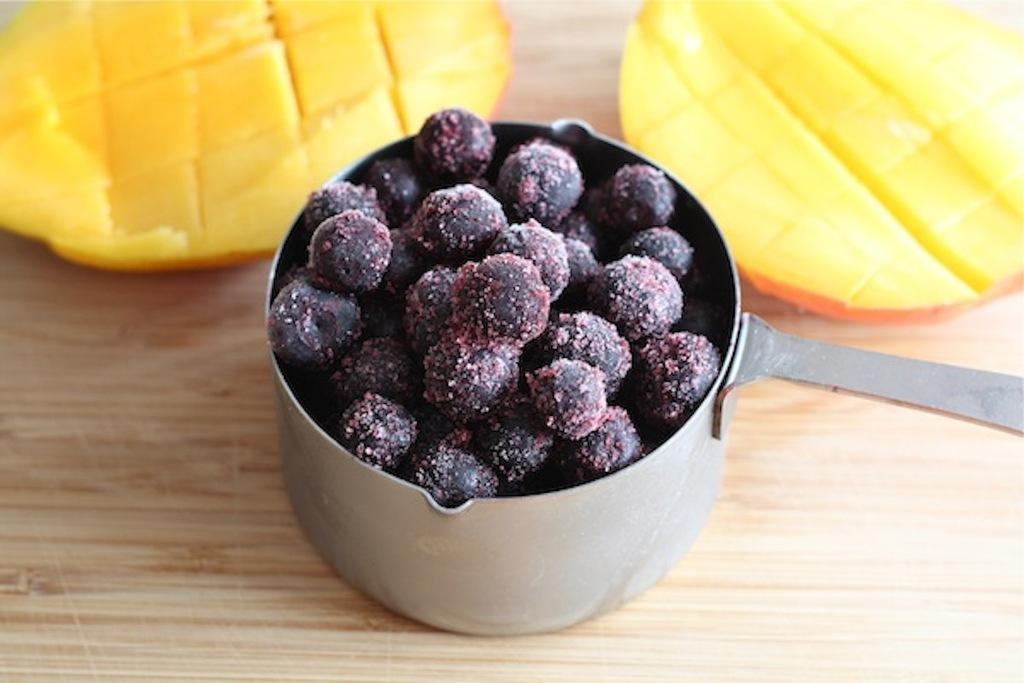What is in the bowl that is visible in the image? There is a bowl with food items in the image. What type of food items are in the bowl? The food items in the bowl resemble fruits. What color are the fruits on the table in the image? There are yellow color fruits on the table in the image. How does the wind affect the arrangement of the fruits on the table in the image? There is no wind present in the image, so it cannot affect the arrangement of the fruits on the table. 